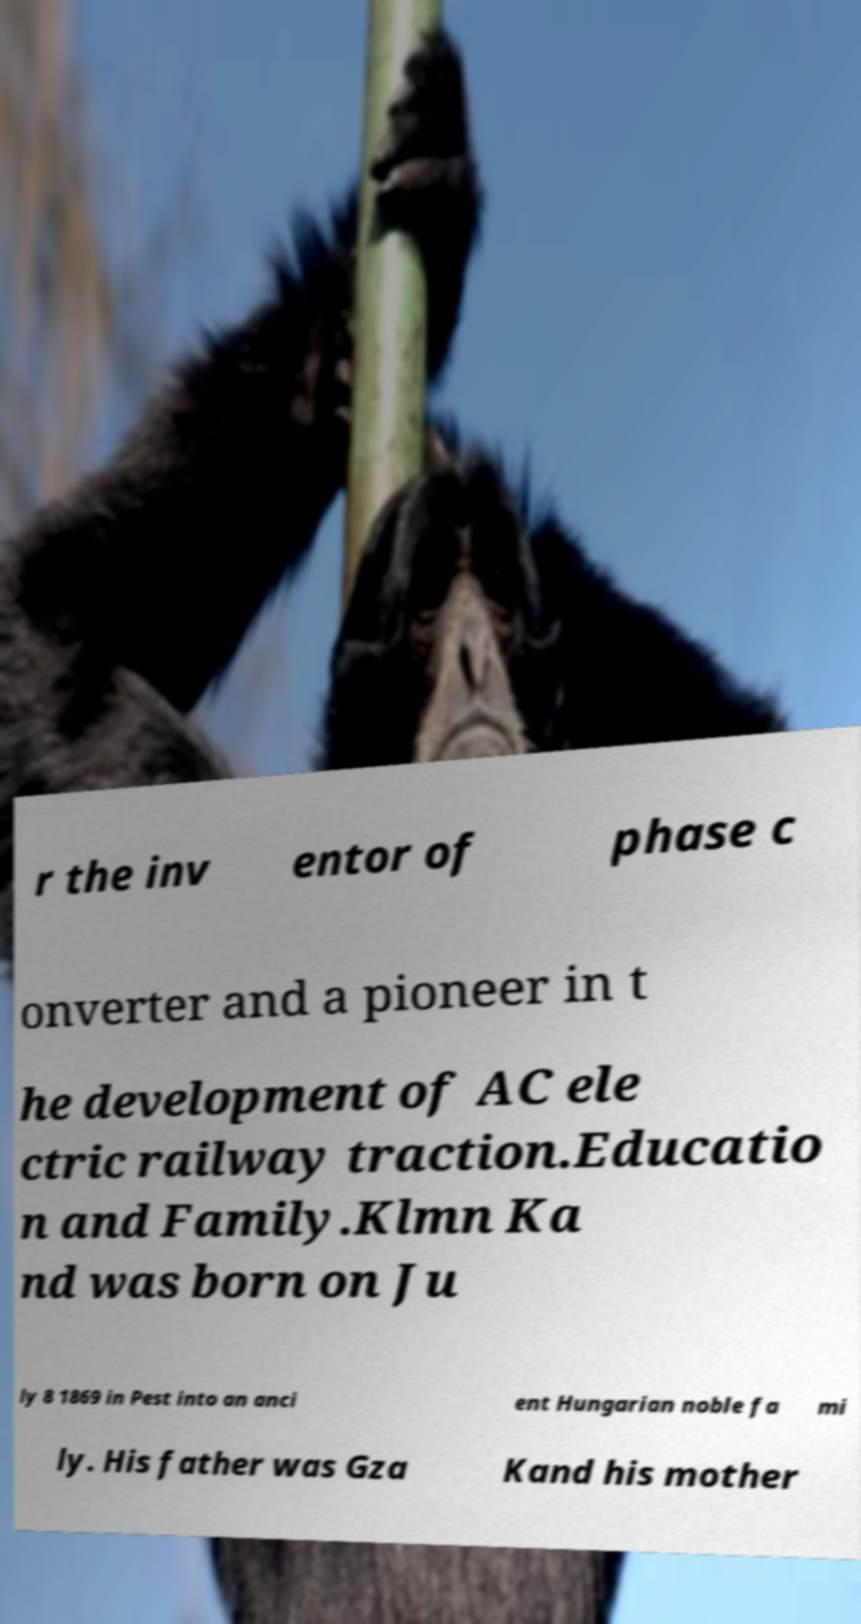I need the written content from this picture converted into text. Can you do that? r the inv entor of phase c onverter and a pioneer in t he development of AC ele ctric railway traction.Educatio n and Family.Klmn Ka nd was born on Ju ly 8 1869 in Pest into an anci ent Hungarian noble fa mi ly. His father was Gza Kand his mother 